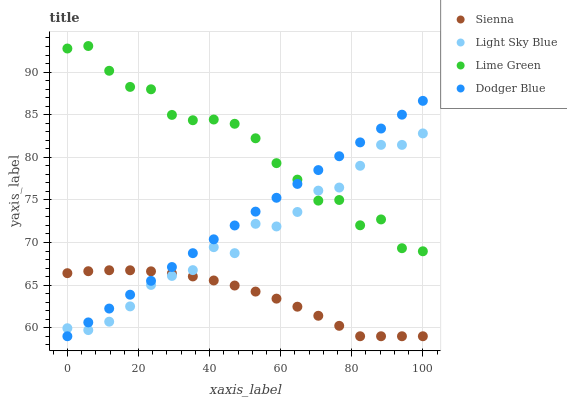Does Sienna have the minimum area under the curve?
Answer yes or no. Yes. Does Lime Green have the maximum area under the curve?
Answer yes or no. Yes. Does Dodger Blue have the minimum area under the curve?
Answer yes or no. No. Does Dodger Blue have the maximum area under the curve?
Answer yes or no. No. Is Dodger Blue the smoothest?
Answer yes or no. Yes. Is Lime Green the roughest?
Answer yes or no. Yes. Is Light Sky Blue the smoothest?
Answer yes or no. No. Is Light Sky Blue the roughest?
Answer yes or no. No. Does Sienna have the lowest value?
Answer yes or no. Yes. Does Light Sky Blue have the lowest value?
Answer yes or no. No. Does Lime Green have the highest value?
Answer yes or no. Yes. Does Dodger Blue have the highest value?
Answer yes or no. No. Is Sienna less than Lime Green?
Answer yes or no. Yes. Is Lime Green greater than Sienna?
Answer yes or no. Yes. Does Light Sky Blue intersect Lime Green?
Answer yes or no. Yes. Is Light Sky Blue less than Lime Green?
Answer yes or no. No. Is Light Sky Blue greater than Lime Green?
Answer yes or no. No. Does Sienna intersect Lime Green?
Answer yes or no. No. 